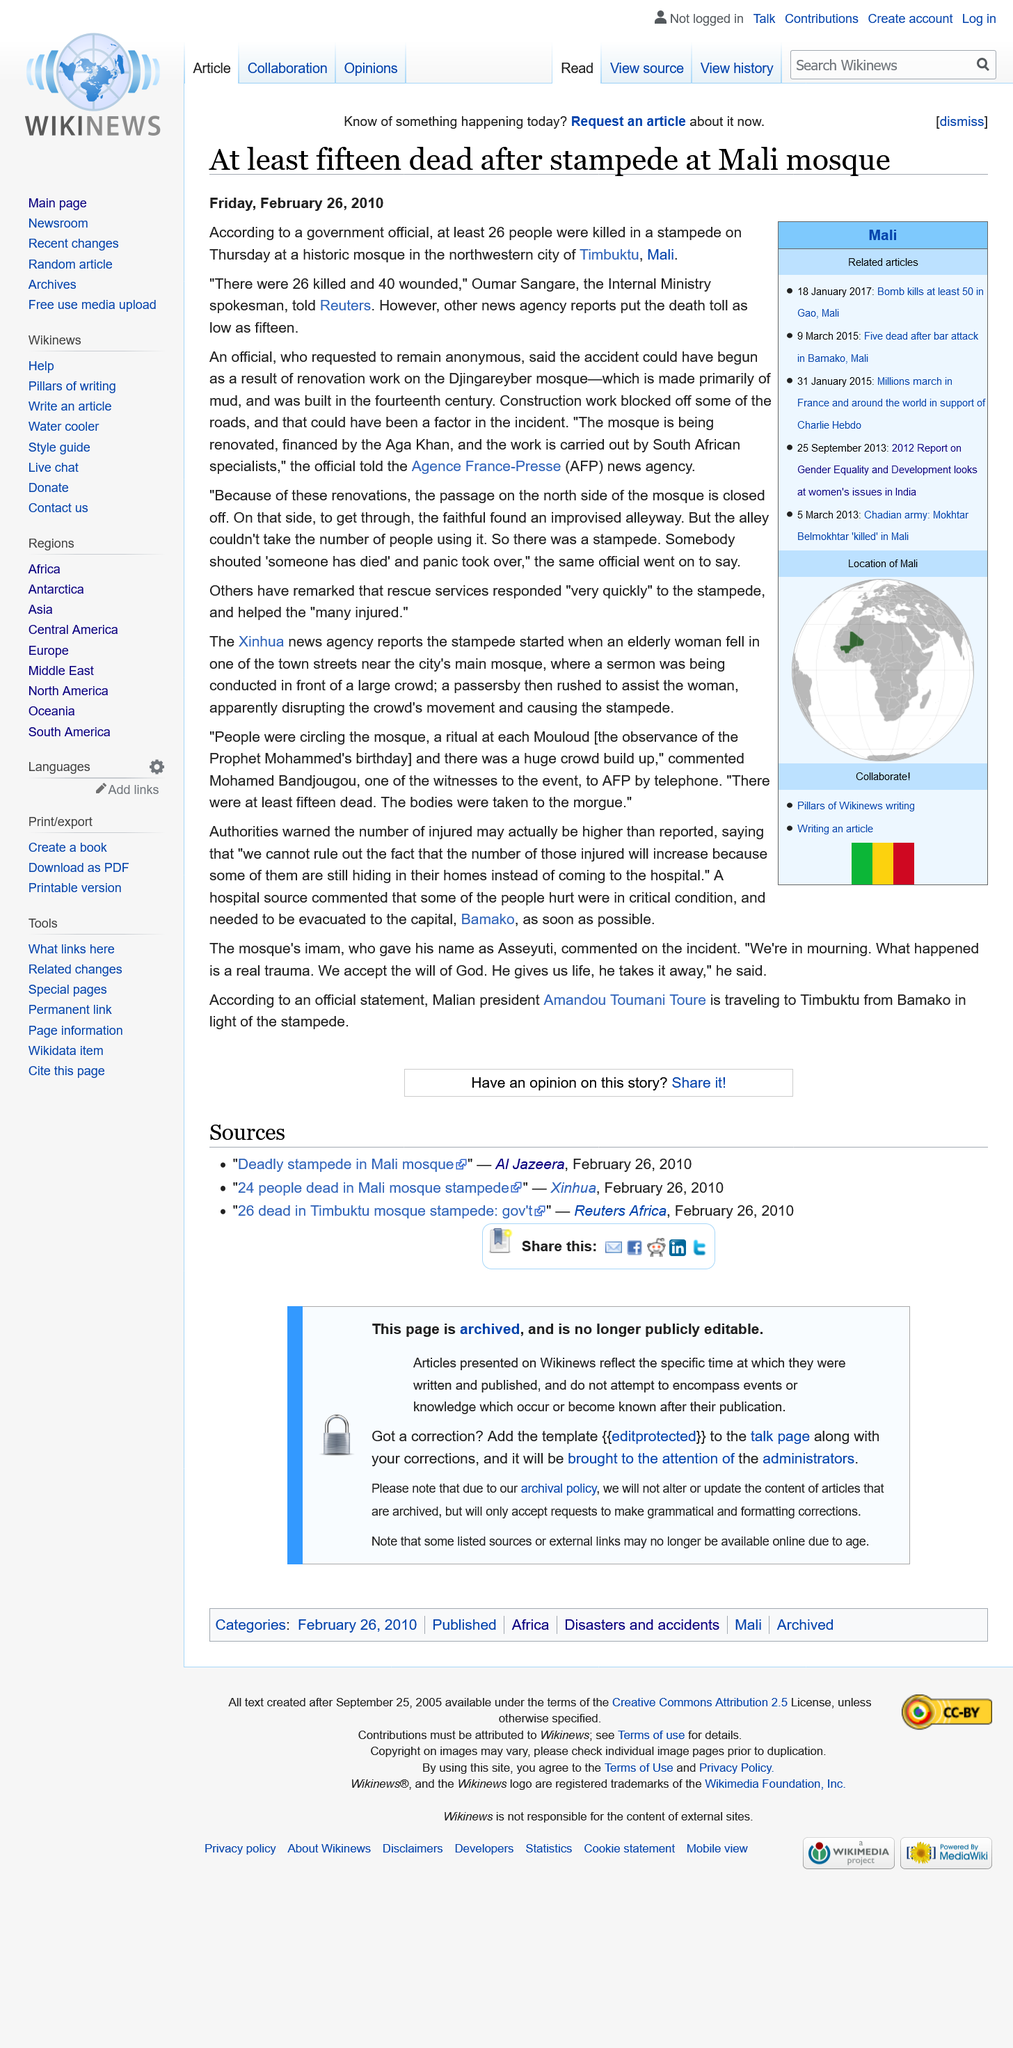Indicate a few pertinent items in this graphic. The stampede took place in a mosque in the city of Timbuktu. The mosque is primarily made of mud. The report regarding the stampede at a Mali mosque is dated Friday, February 26, 2010, and it is the date of the report. 